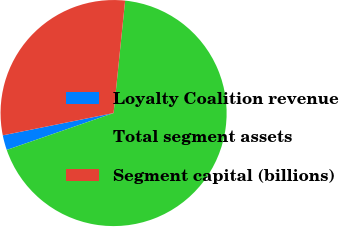Convert chart. <chart><loc_0><loc_0><loc_500><loc_500><pie_chart><fcel>Loyalty Coalition revenue<fcel>Total segment assets<fcel>Segment capital (billions)<nl><fcel>2.13%<fcel>68.09%<fcel>29.79%<nl></chart> 